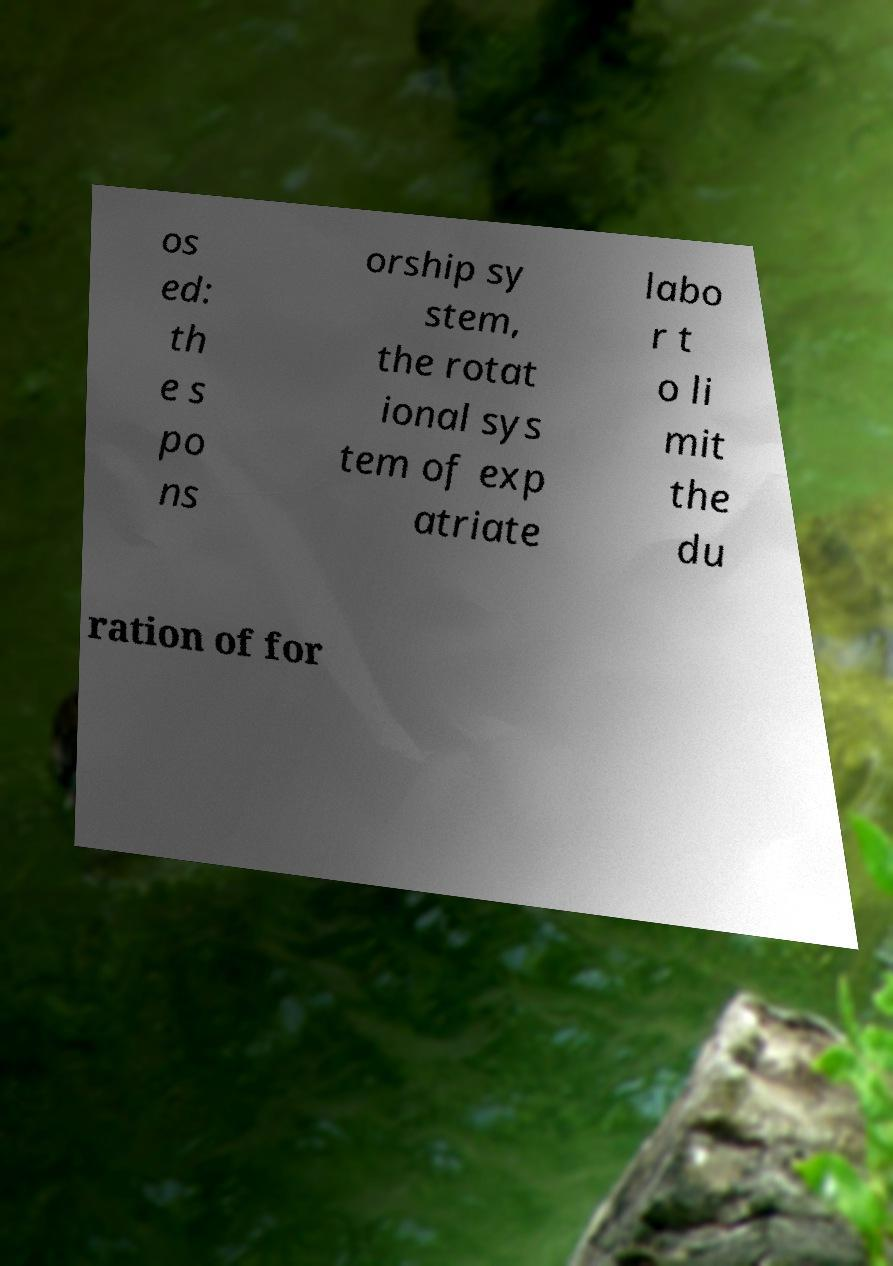What messages or text are displayed in this image? I need them in a readable, typed format. os ed: th e s po ns orship sy stem, the rotat ional sys tem of exp atriate labo r t o li mit the du ration of for 